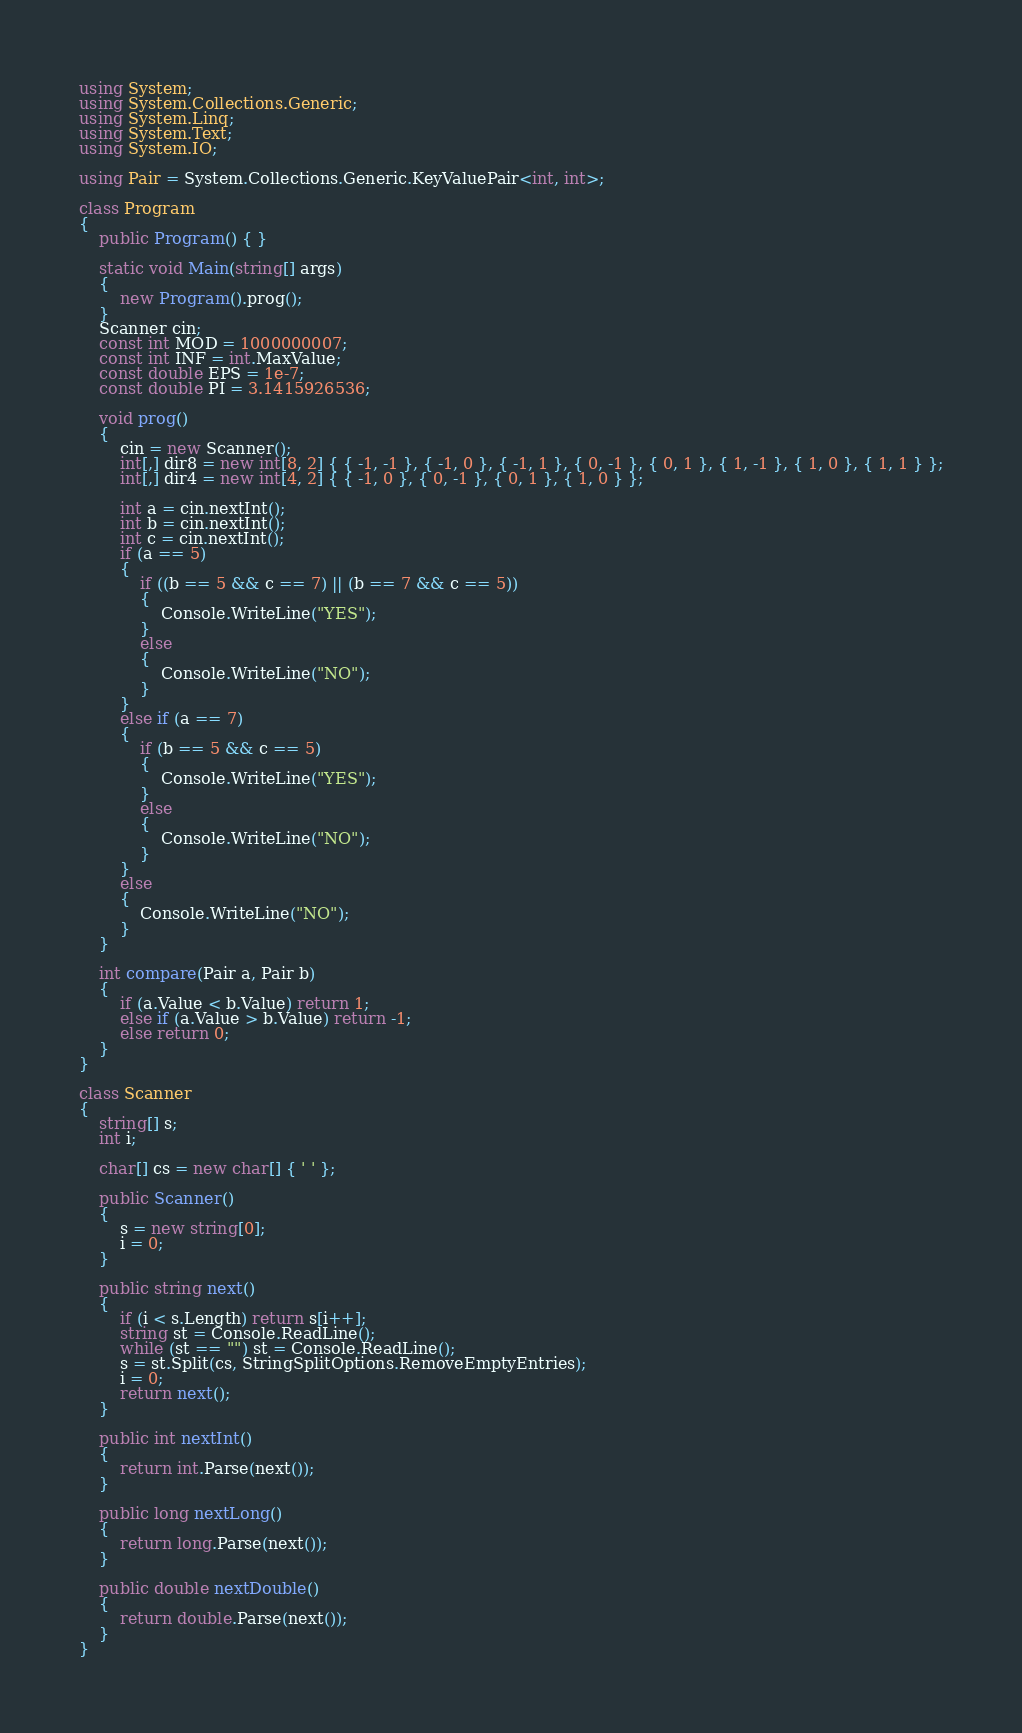Convert code to text. <code><loc_0><loc_0><loc_500><loc_500><_C#_>using System;
using System.Collections.Generic;
using System.Linq;
using System.Text;
using System.IO;

using Pair = System.Collections.Generic.KeyValuePair<int, int>;

class Program
{
	public Program() { }

	static void Main(string[] args)
	{
		new Program().prog();
	}
	Scanner cin;
	const int MOD = 1000000007;
	const int INF = int.MaxValue;
	const double EPS = 1e-7;
	const double PI = 3.1415926536;

	void prog()
	{
		cin = new Scanner();
		int[,] dir8 = new int[8, 2] { { -1, -1 }, { -1, 0 }, { -1, 1 }, { 0, -1 }, { 0, 1 }, { 1, -1 }, { 1, 0 }, { 1, 1 } };
		int[,] dir4 = new int[4, 2] { { -1, 0 }, { 0, -1 }, { 0, 1 }, { 1, 0 } };

		int a = cin.nextInt();
		int b = cin.nextInt();
		int c = cin.nextInt();
		if (a == 5)
		{
			if ((b == 5 && c == 7) || (b == 7 && c == 5))
			{
				Console.WriteLine("YES");
			}
			else
			{
				Console.WriteLine("NO");
			}
		}
		else if (a == 7)
		{
			if (b == 5 && c == 5)
			{
				Console.WriteLine("YES");
			}
			else
			{
				Console.WriteLine("NO");
			}
		}
		else
		{
			Console.WriteLine("NO");
		}
	}

	int compare(Pair a, Pair b)
	{
		if (a.Value < b.Value) return 1;
		else if (a.Value > b.Value) return -1;
		else return 0;
	}
}

class Scanner
{
	string[] s;
	int i;

	char[] cs = new char[] { ' ' };

	public Scanner()
	{
		s = new string[0];
		i = 0;
	}

	public string next()
	{
		if (i < s.Length) return s[i++];
		string st = Console.ReadLine();
		while (st == "") st = Console.ReadLine();
		s = st.Split(cs, StringSplitOptions.RemoveEmptyEntries);
		i = 0;
		return next();
	}

	public int nextInt()
	{
		return int.Parse(next());
	}

	public long nextLong()
	{
		return long.Parse(next());
	}

	public double nextDouble()
	{
		return double.Parse(next());
	}
}</code> 